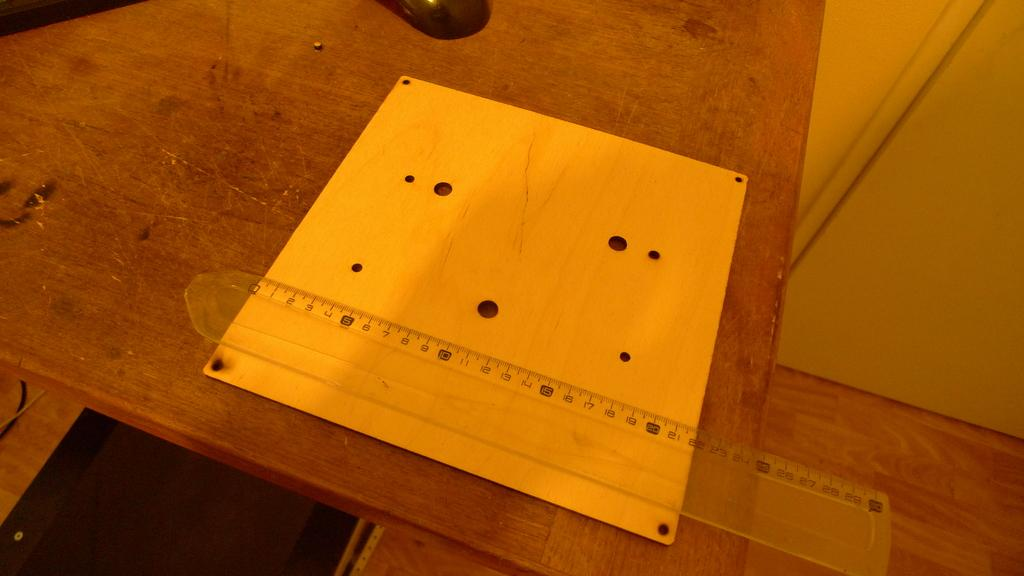What type of furniture is present in the image? There is a table in the image. What color is the object on the table? The object on the table is yellow. What tool is used for measuring in the image? There is a measurement scale on the table. What is the color of the other visible object in the image? The other visible object is black. What type of hydrant is visible in the image? There is no hydrant present in the image. What meal is being prepared on the table in the image? There is no meal preparation visible in the image; it only shows a table with objects on it. 